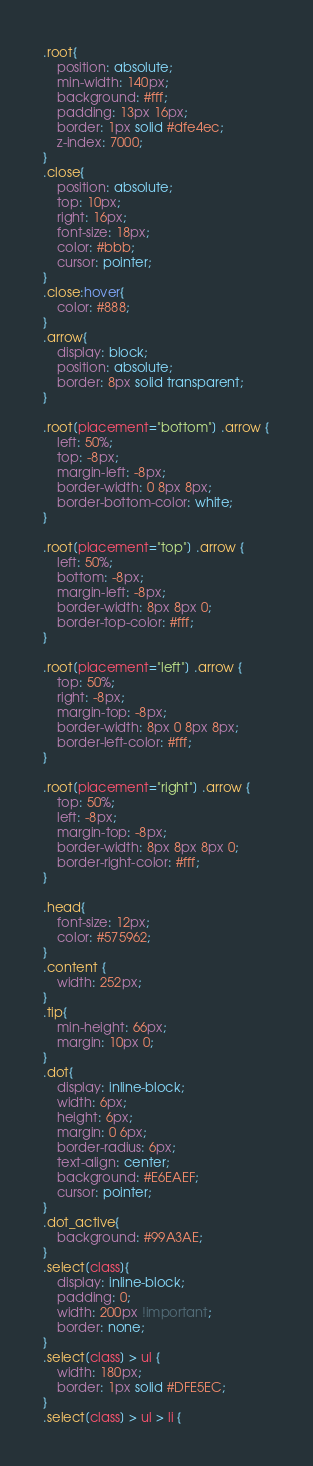Convert code to text. <code><loc_0><loc_0><loc_500><loc_500><_CSS_>.root{
    position: absolute;
    min-width: 140px;
    background: #fff;
    padding: 13px 16px;
    border: 1px solid #dfe4ec;
    z-index: 7000;
}
.close{
    position: absolute;
    top: 10px;
    right: 16px;
    font-size: 18px;
    color: #bbb;
    cursor: pointer;
}
.close:hover{
    color: #888;
}
.arrow{
    display: block;
    position: absolute;
    border: 8px solid transparent;
}

.root[placement="bottom"] .arrow {
    left: 50%;
    top: -8px;
    margin-left: -8px;
    border-width: 0 8px 8px;
    border-bottom-color: white;
}

.root[placement="top"] .arrow {
    left: 50%;
    bottom: -8px;
    margin-left: -8px;
    border-width: 8px 8px 0;
    border-top-color: #fff;
}

.root[placement="left"] .arrow {
    top: 50%;
    right: -8px;
    margin-top: -8px;
    border-width: 8px 0 8px 8px;
    border-left-color: #fff;
}

.root[placement="right"] .arrow {
    top: 50%;
    left: -8px;
    margin-top: -8px;
    border-width: 8px 8px 8px 0;
    border-right-color: #fff;
}

.head{
    font-size: 12px;
    color: #575962;
}
.content {
    width: 252px;
}
.tip{
    min-height: 66px;
    margin: 10px 0;
}
.dot{
    display: inline-block;
    width: 6px;
    height: 6px;
    margin: 0 6px;
    border-radius: 6px;
    text-align: center;
    background: #E6EAEF;
    cursor: pointer;
}
.dot_active{
    background: #99A3AE;
}
.select[class]{
    display: inline-block;
    padding: 0;
    width: 200px !important;
    border: none;
}
.select[class] > ul {
    width: 180px;
    border: 1px solid #DFE5EC;
}
.select[class] > ul > li {</code> 